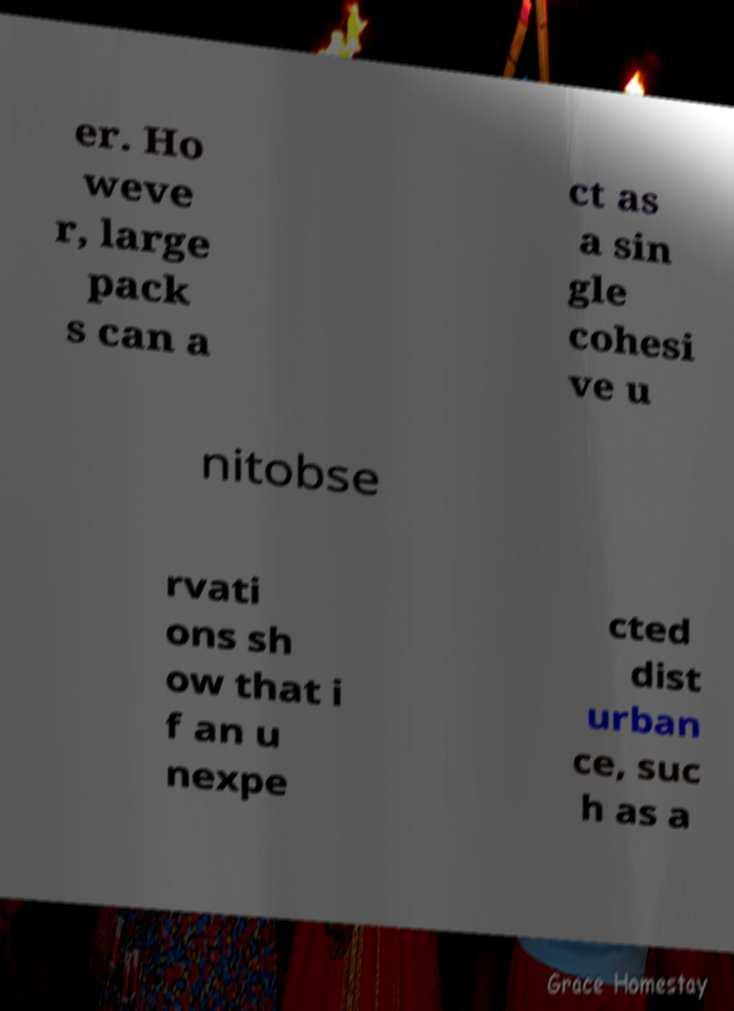Can you read and provide the text displayed in the image?This photo seems to have some interesting text. Can you extract and type it out for me? er. Ho weve r, large pack s can a ct as a sin gle cohesi ve u nitobse rvati ons sh ow that i f an u nexpe cted dist urban ce, suc h as a 